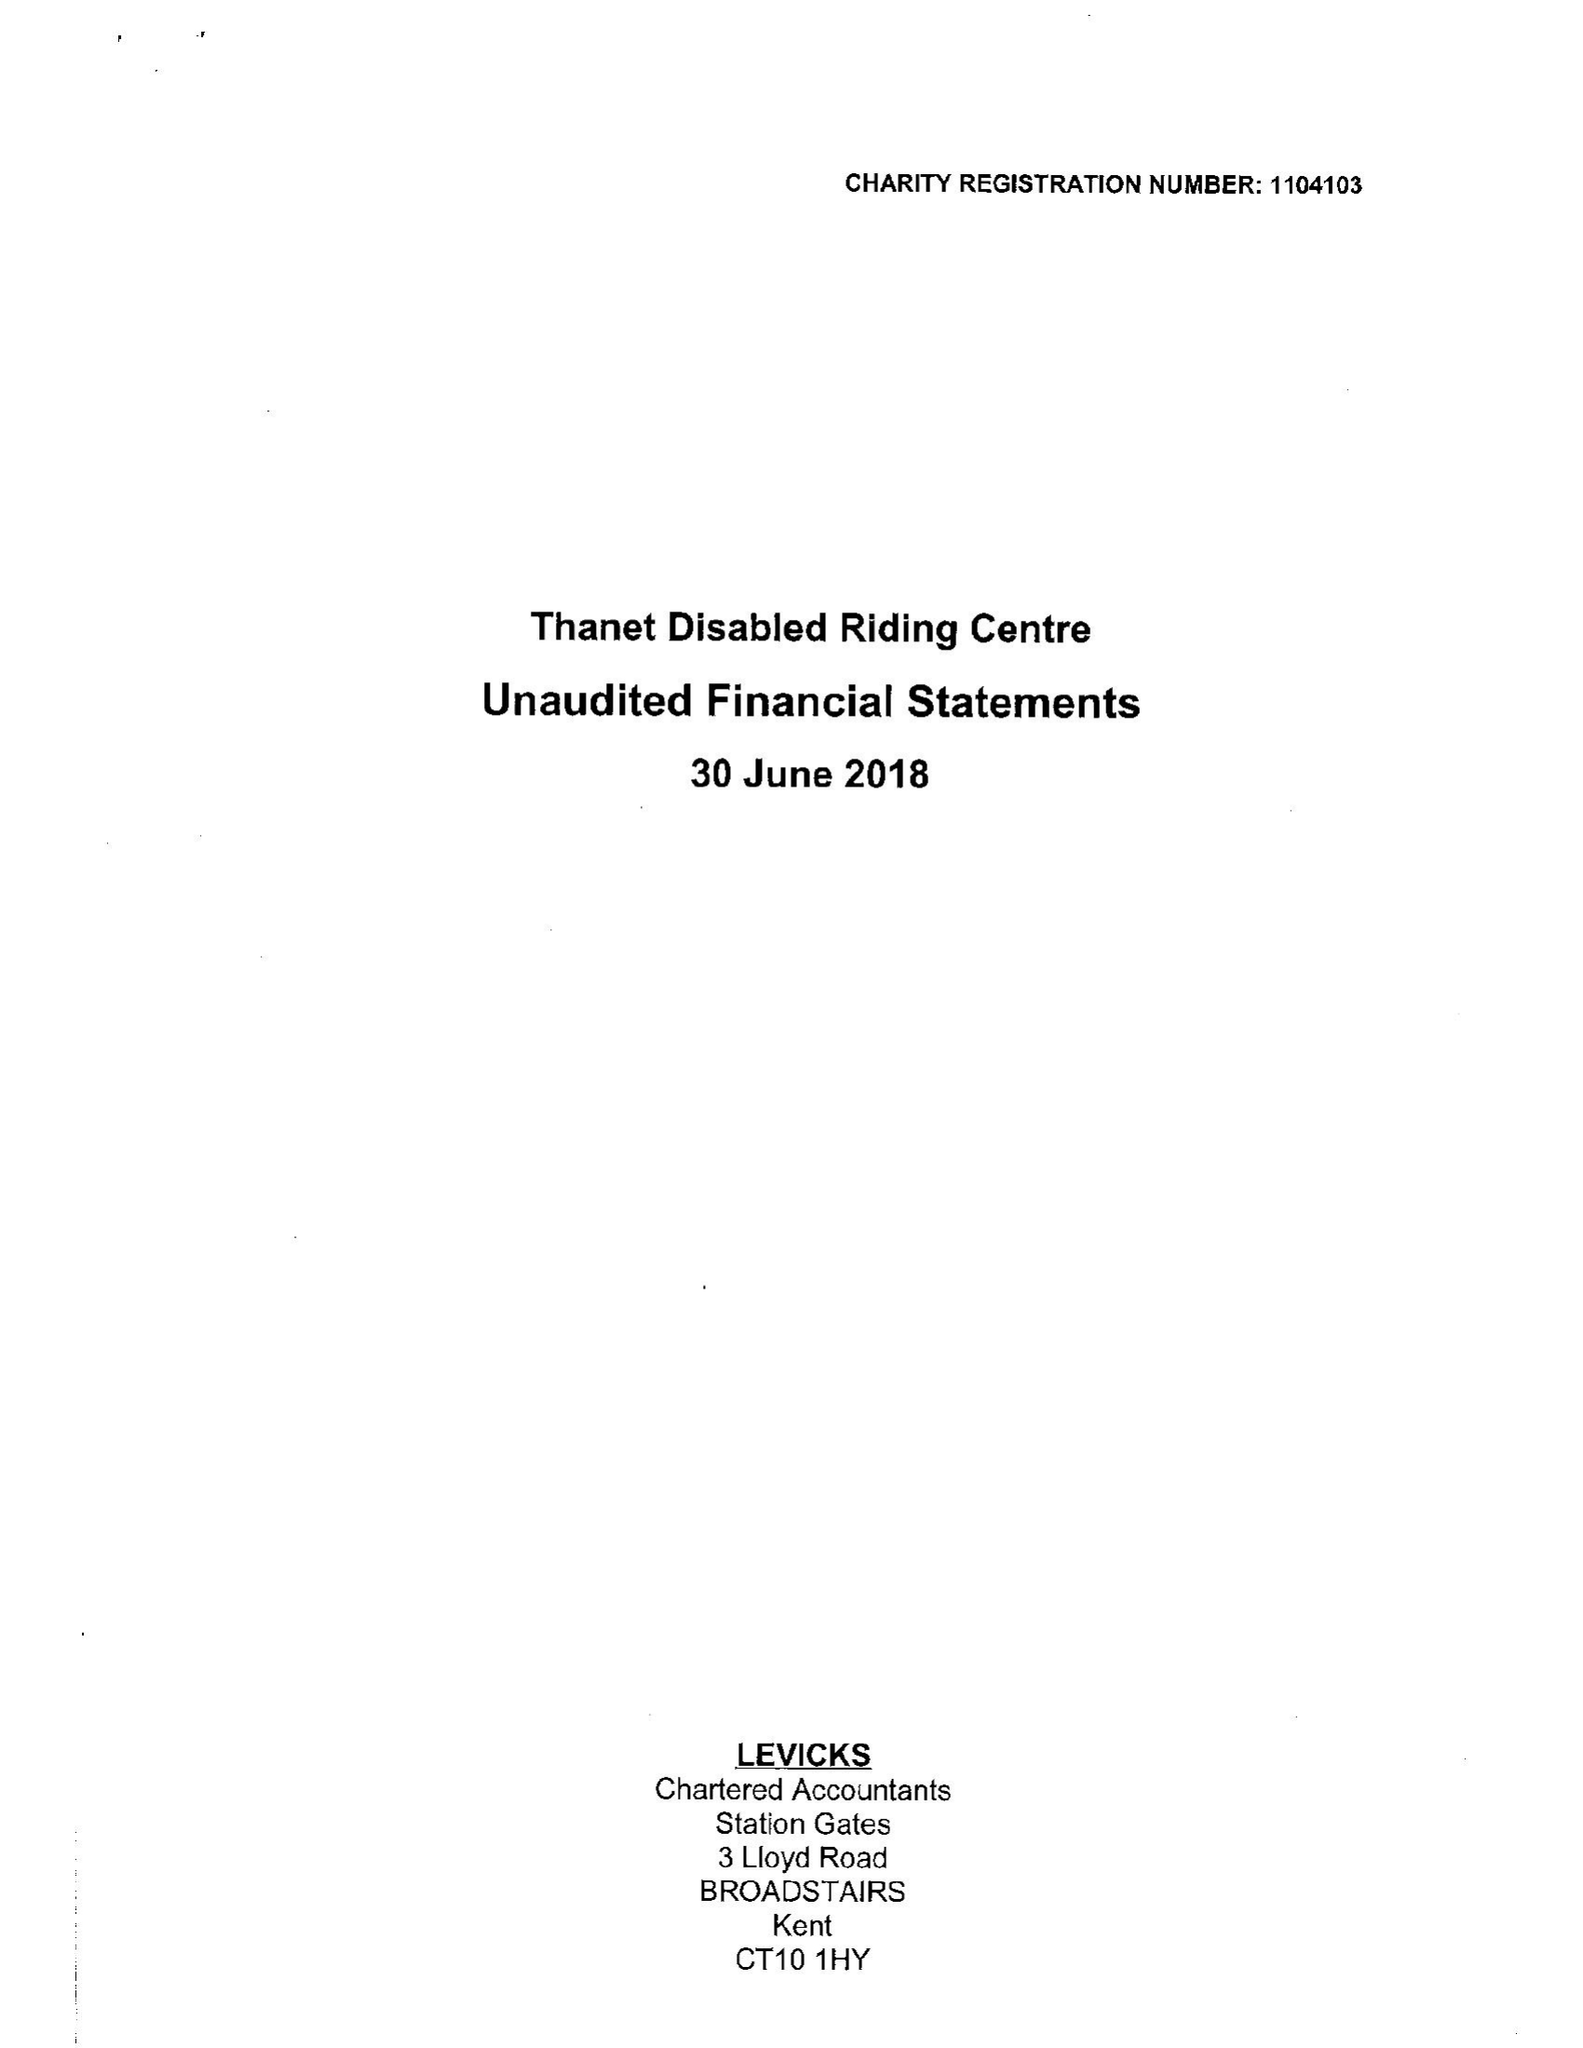What is the value for the charity_name?
Answer the question using a single word or phrase. Thanet Disabled Riding Centre 